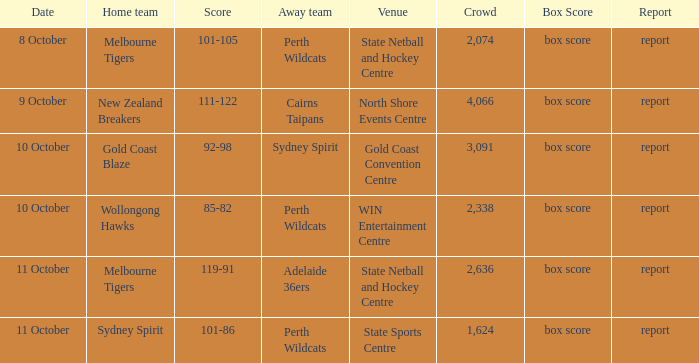What was the crowd size for the game with a score of 101-105? 2074.0. 